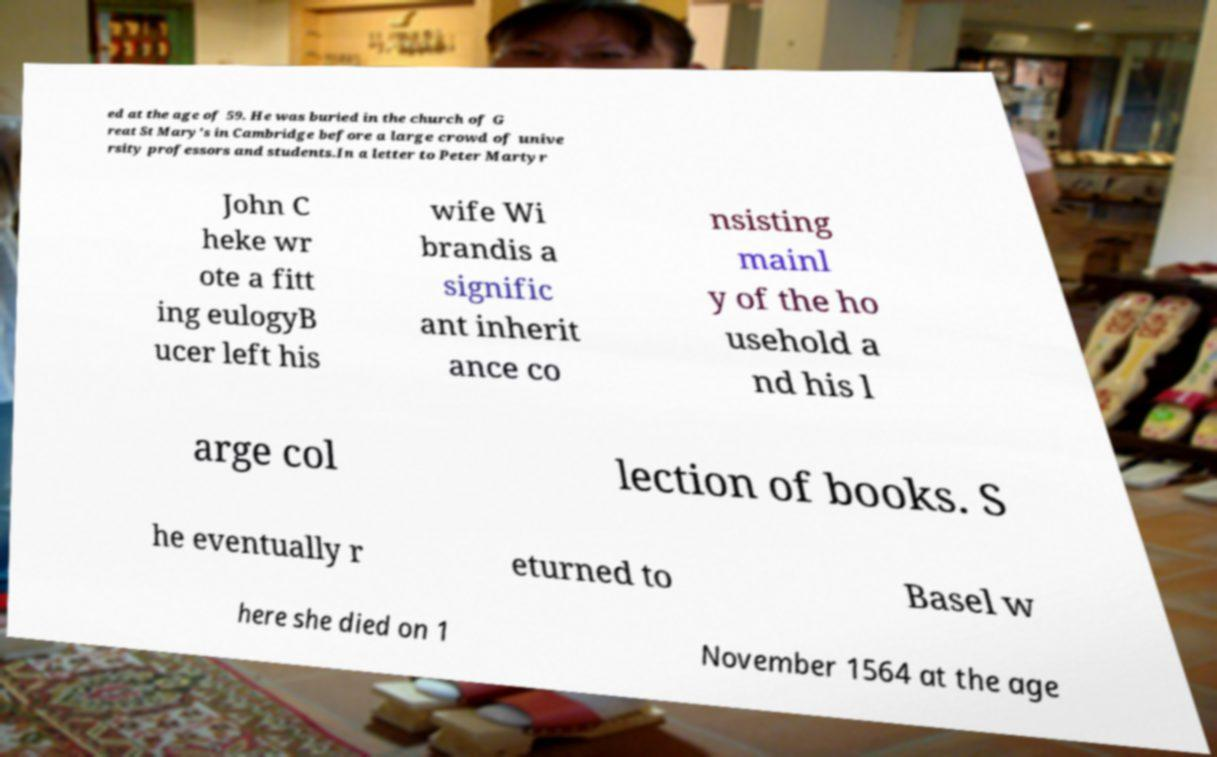Please read and relay the text visible in this image. What does it say? ed at the age of 59. He was buried in the church of G reat St Mary's in Cambridge before a large crowd of unive rsity professors and students.In a letter to Peter Martyr John C heke wr ote a fitt ing eulogyB ucer left his wife Wi brandis a signific ant inherit ance co nsisting mainl y of the ho usehold a nd his l arge col lection of books. S he eventually r eturned to Basel w here she died on 1 November 1564 at the age 